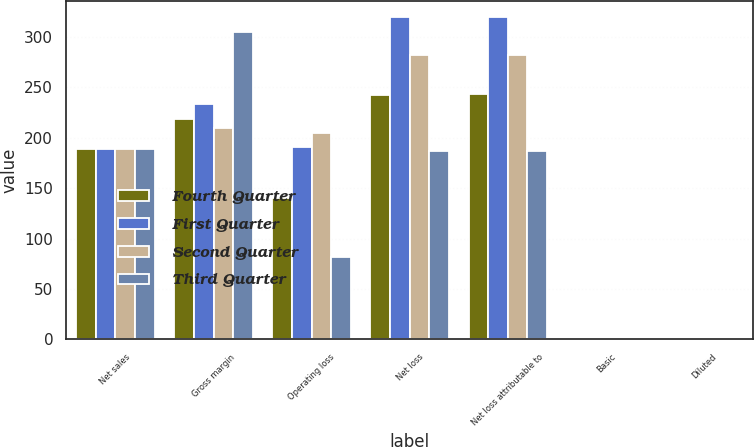Convert chart to OTSL. <chart><loc_0><loc_0><loc_500><loc_500><stacked_bar_chart><ecel><fcel>Net sales<fcel>Gross margin<fcel>Operating loss<fcel>Net loss<fcel>Net loss attributable to<fcel>Basic<fcel>Diluted<nl><fcel>Fourth Quarter<fcel>189<fcel>219<fcel>140<fcel>242<fcel>243<fcel>0.24<fcel>0.24<nl><fcel>First Quarter<fcel>189<fcel>234<fcel>191<fcel>320<fcel>320<fcel>0.32<fcel>0.32<nl><fcel>Second Quarter<fcel>189<fcel>210<fcel>205<fcel>282<fcel>282<fcel>0.29<fcel>0.29<nl><fcel>Third Quarter<fcel>189<fcel>305<fcel>82<fcel>187<fcel>187<fcel>0.19<fcel>0.19<nl></chart> 